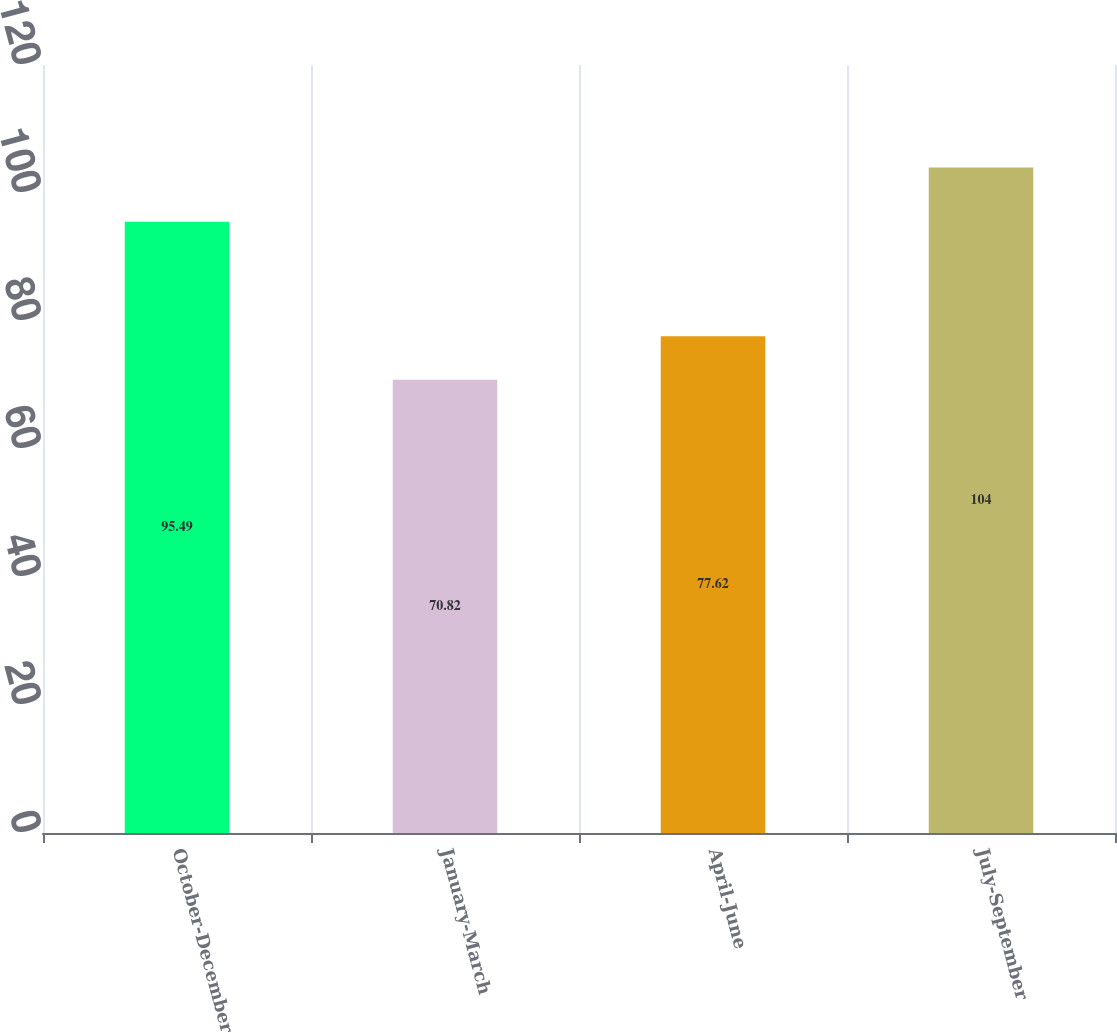Convert chart to OTSL. <chart><loc_0><loc_0><loc_500><loc_500><bar_chart><fcel>October-December<fcel>January-March<fcel>April-June<fcel>July-September<nl><fcel>95.49<fcel>70.82<fcel>77.62<fcel>104<nl></chart> 